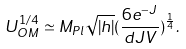Convert formula to latex. <formula><loc_0><loc_0><loc_500><loc_500>U _ { O M } ^ { 1 / 4 } \simeq M _ { P l } \sqrt { | h | } ( \frac { 6 e ^ { - J } } { d J V } ) ^ { \frac { 1 } { 4 } } .</formula> 